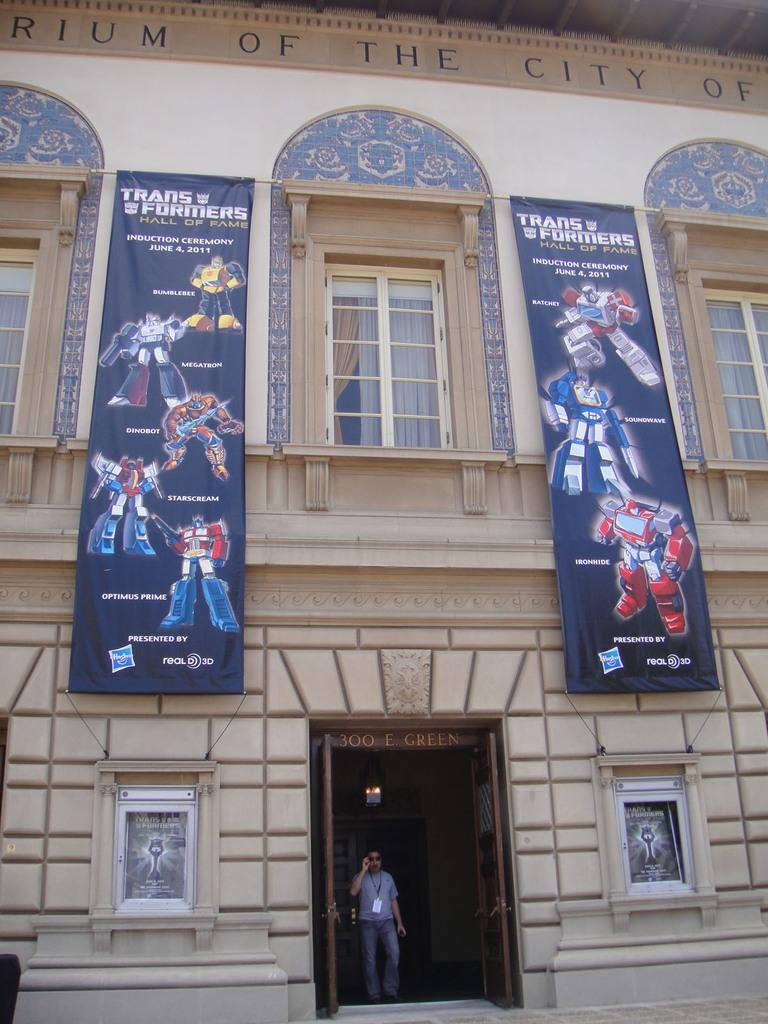What is the main subject in the foreground of the image? There is a building in the foreground of the image. What other objects can be seen in the foreground of the image? There are boards, posters, windows, a person, and a door in the foreground of the image. Can you describe the setting of the image? The image is likely taken outside the building. What type of beetle can be seen crawling on the person in the image? There is no beetle present in the image; only the building, boards, posters, windows, person, and door are visible. 